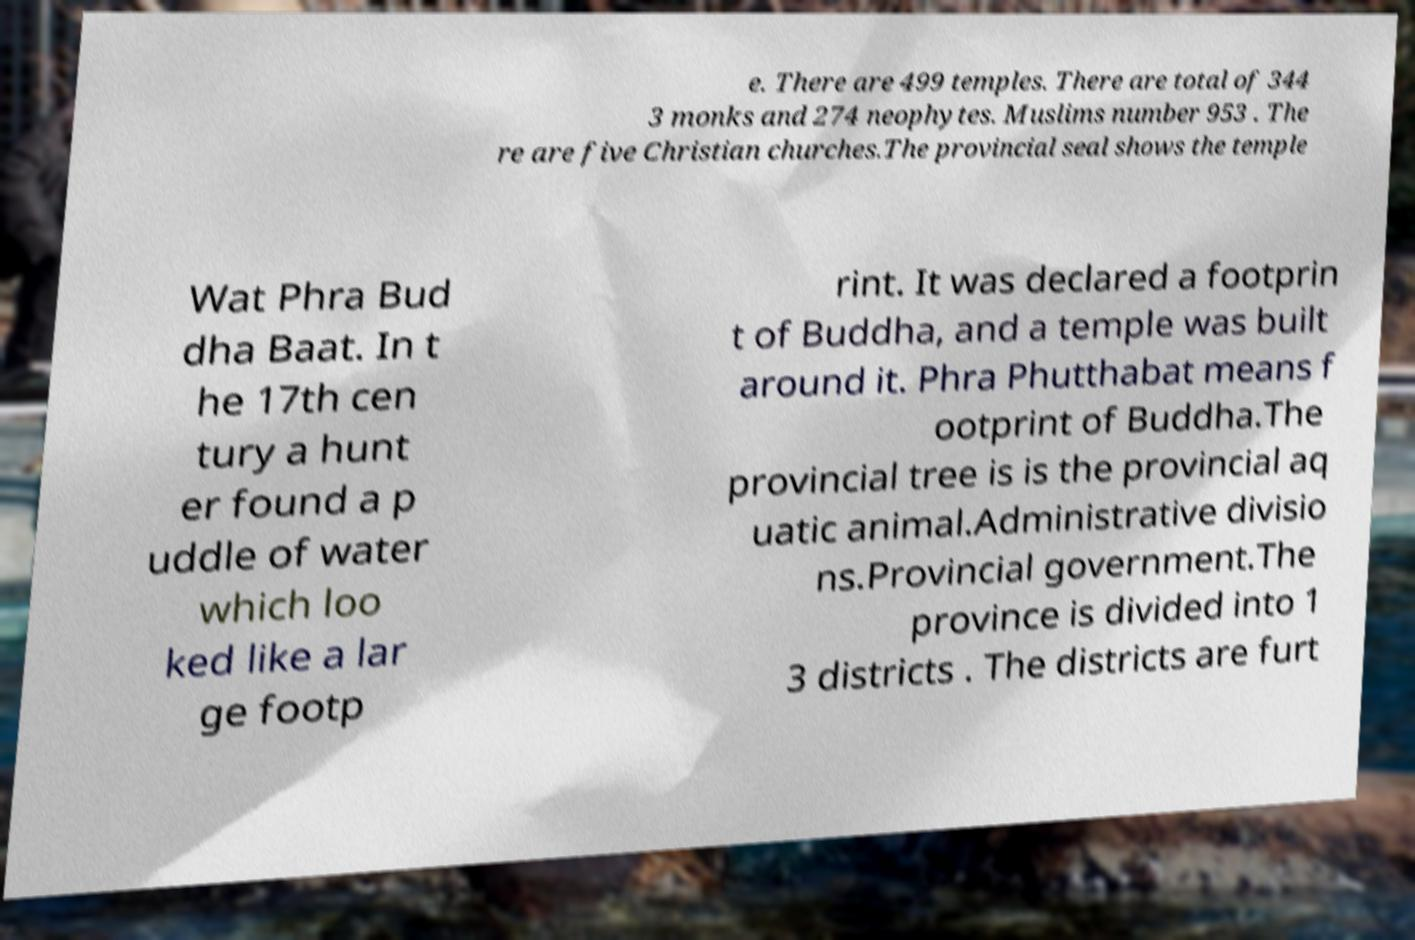Can you read and provide the text displayed in the image?This photo seems to have some interesting text. Can you extract and type it out for me? e. There are 499 temples. There are total of 344 3 monks and 274 neophytes. Muslims number 953 . The re are five Christian churches.The provincial seal shows the temple Wat Phra Bud dha Baat. In t he 17th cen tury a hunt er found a p uddle of water which loo ked like a lar ge footp rint. It was declared a footprin t of Buddha, and a temple was built around it. Phra Phutthabat means f ootprint of Buddha.The provincial tree is is the provincial aq uatic animal.Administrative divisio ns.Provincial government.The province is divided into 1 3 districts . The districts are furt 